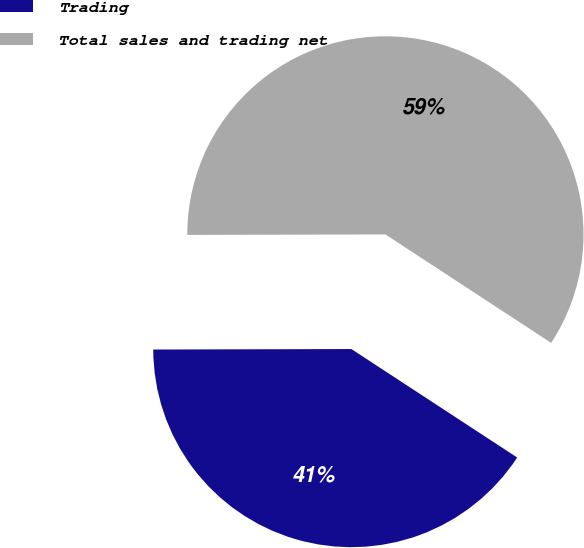Convert chart. <chart><loc_0><loc_0><loc_500><loc_500><pie_chart><fcel>Trading<fcel>Total sales and trading net<nl><fcel>40.74%<fcel>59.26%<nl></chart> 